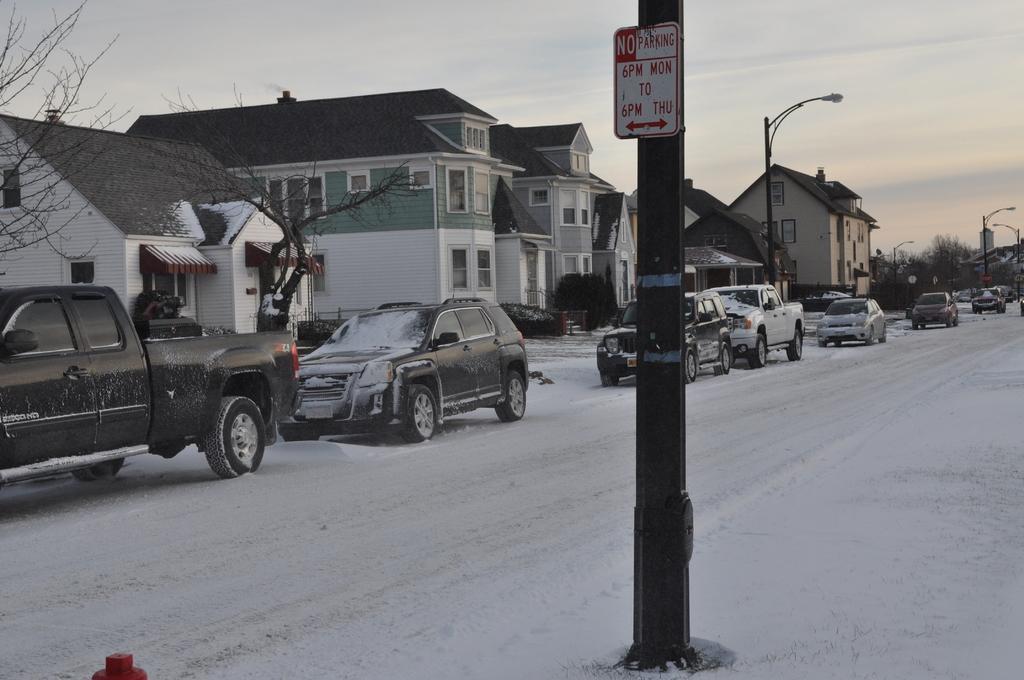In one or two sentences, can you explain what this image depicts? In this image I can see poles, boards, fleets of vehicles on the road, snow, buildings, trees, windows, light poles and the sky. This image is taken may be during a day. 